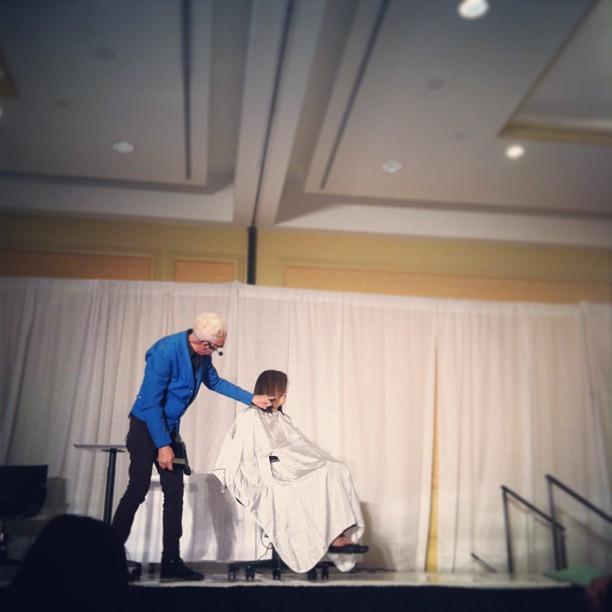How many people can be seen?
Give a very brief answer. 2. 